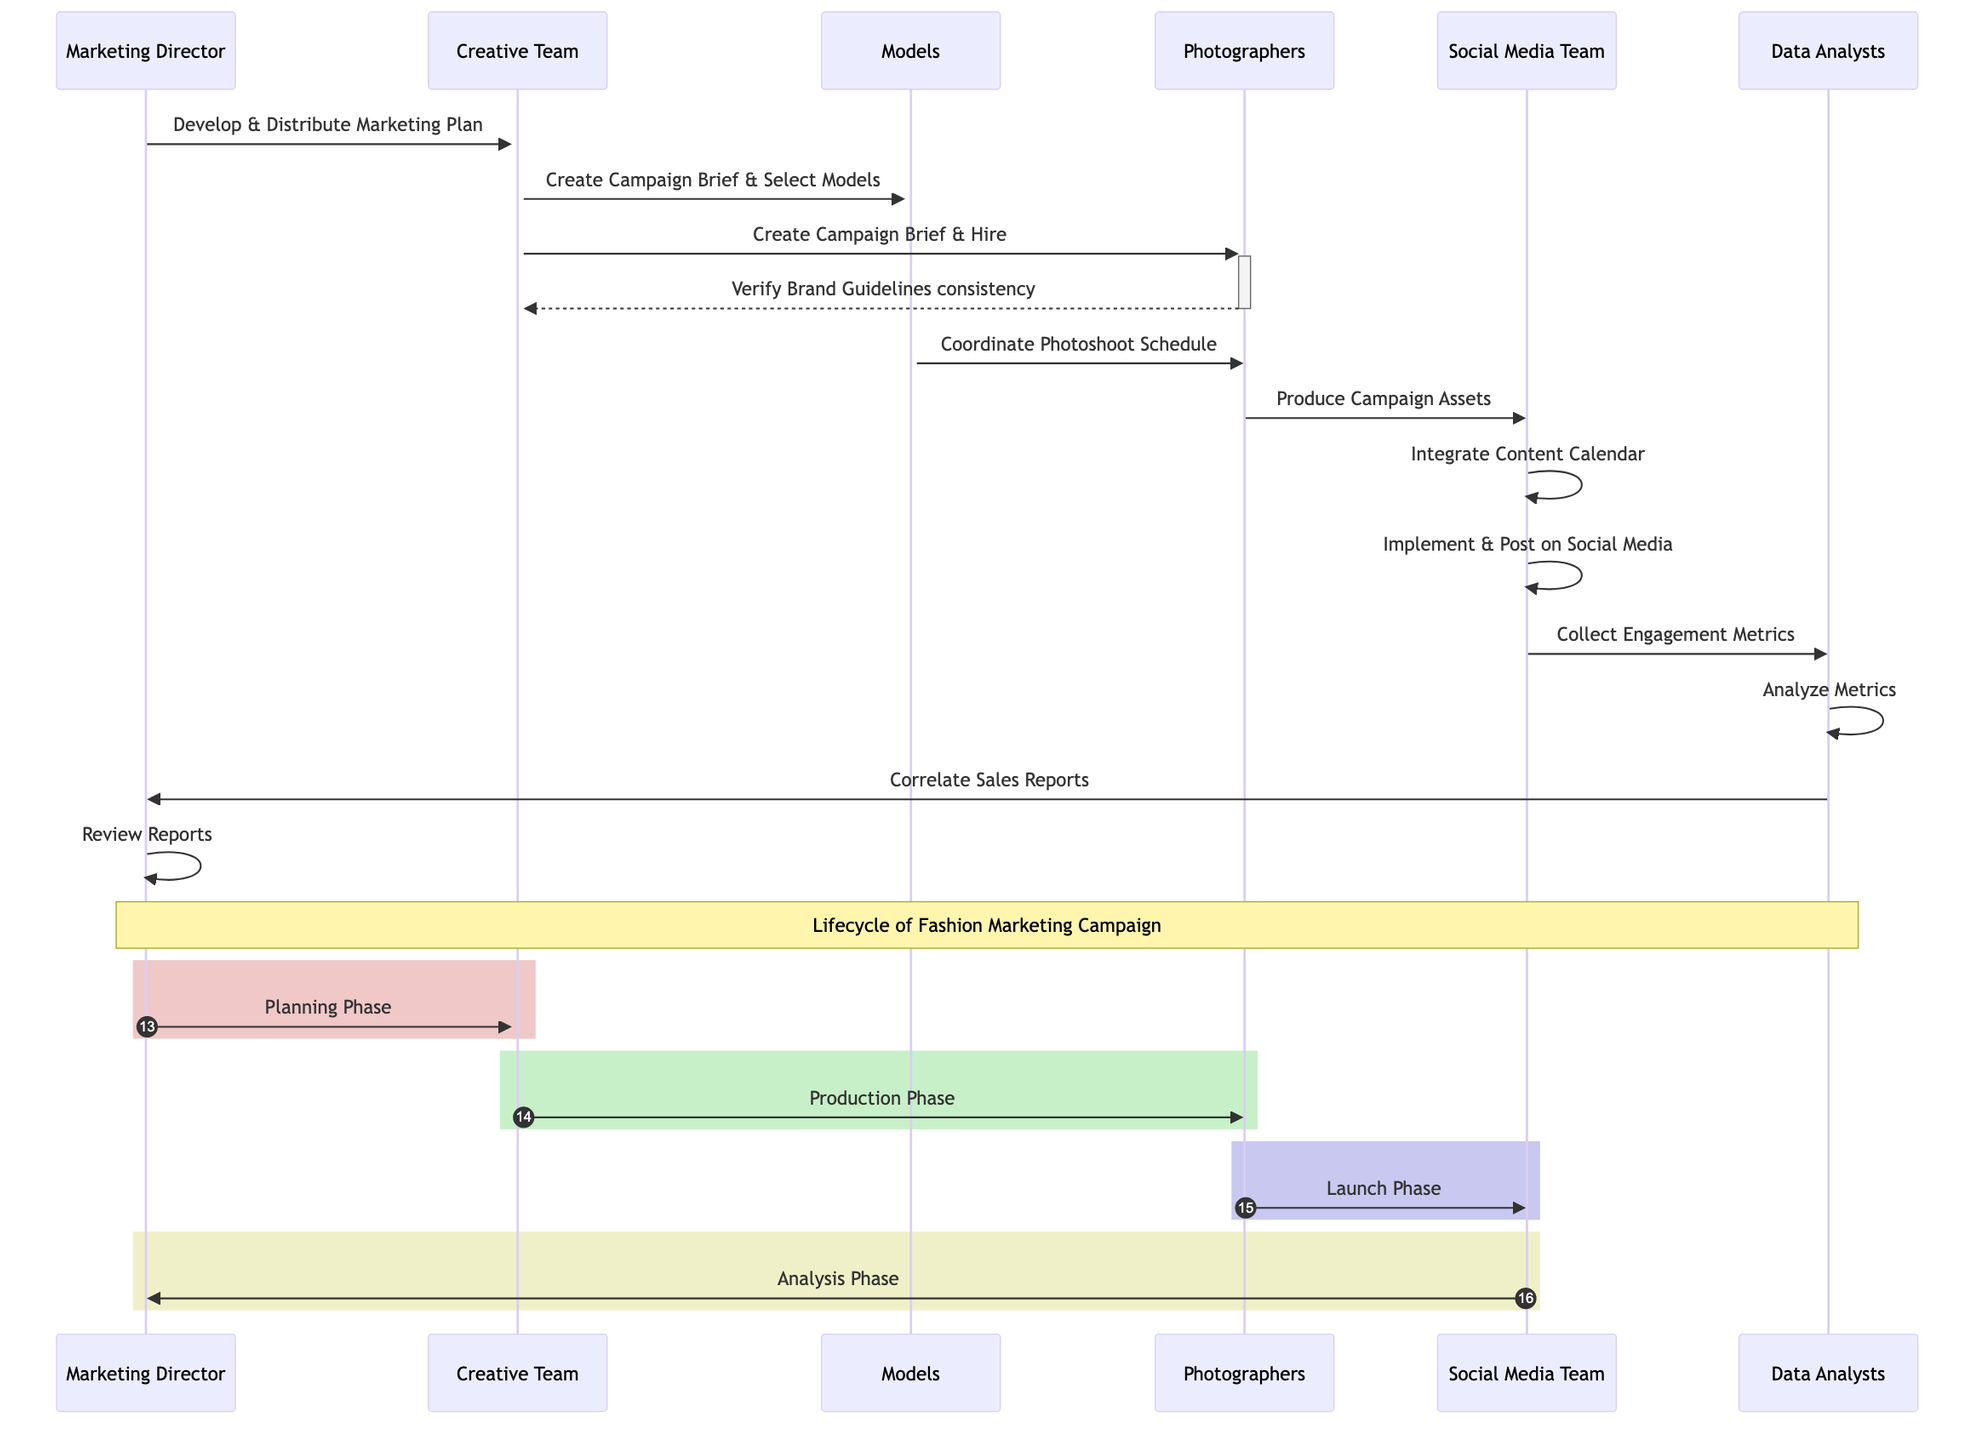What is the first action taken by the Marketing Director? The first action in the sequence diagram is denoted by the arrow from the Marketing Director to the Marketing Plan, stating "Develop." This indicates the initial step in the campaign lifecycle.
Answer: Develop How many actors are involved in the campaign lifecycle? By analyzing the diagram, we can count the different roles labeled as participants. There are six distinct actors: Marketing Director, Creative Team, Models, Photographers, Social Media Team, and Data Analysts.
Answer: Six Which object is created by the Creative Team? The diagram shows that the Creative Team's interaction leads to the creation of the Campaign Brief. The action "Create" is directly linked to the object Campaign Brief in the flow of the diagram.
Answer: Campaign Brief What does the Social Media Team collect at the launch phase? The interaction from the Social Media Platforms indicates that they collect Engagement Metrics, which is part of their responsibility in the launch phase of the campaign as shown in the diagram.
Answer: Engagement Metrics In which phase does the Marketing Director review the Sales Reports? The diagram specifies that the Marketing Director reviews the Sales Reports during the Analysis Phase, marked as a distinct segment shown in the lifecycle visually represented in the diagram.
Answer: Analysis Phase Who produces the Campaign Assets? The interaction from Photographers indicates that they are responsible for producing the Campaign Assets, as highlighted in the diagram with the action "Produce."
Answer: Photographers What is the final action in the campaign lifecycle? As we trace the final interactions, the last arrow points from Data Analysts to Marketing Director with the action "Review," denoting the final evaluation of the campaign's success evident in the flow of the diagram.
Answer: Review Which team implements the Content Calendar? The diagram clearly indicates that the Social Media Team is responsible for implementing the Content Calendar, as shown by their specific interaction with the calendar in the sequence.
Answer: Social Media Team 